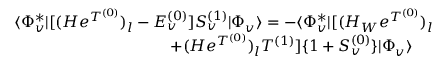<formula> <loc_0><loc_0><loc_500><loc_500>\begin{array} { r l r } { \langle \Phi _ { v } ^ { * } | [ ( H e ^ { T ^ { ( 0 ) } } ) _ { l } - E _ { v } ^ { ( 0 ) } ] S _ { v } ^ { ( 1 ) } | \Phi _ { v } \rangle = - \langle \Phi _ { v } ^ { * } | [ ( H _ { W } e ^ { T ^ { ( 0 ) } } ) _ { l } } & \\ { + ( H e ^ { T ^ { ( 0 ) } } ) _ { l } T ^ { ( 1 ) } ] \{ 1 + S _ { v } ^ { ( 0 ) } \} | \Phi _ { v } \rangle \quad } \end{array}</formula> 